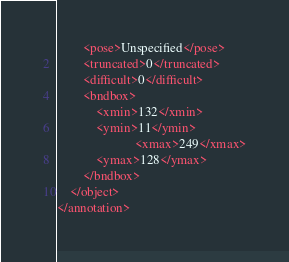<code> <loc_0><loc_0><loc_500><loc_500><_XML_>		<pose>Unspecified</pose>
		<truncated>0</truncated>
		<difficult>0</difficult>
		<bndbox>
			<xmin>132</xmin>
			<ymin>11</ymin>
                        <xmax>249</xmax>
			<ymax>128</ymax>
		</bndbox>
	</object>
</annotation>
</code> 